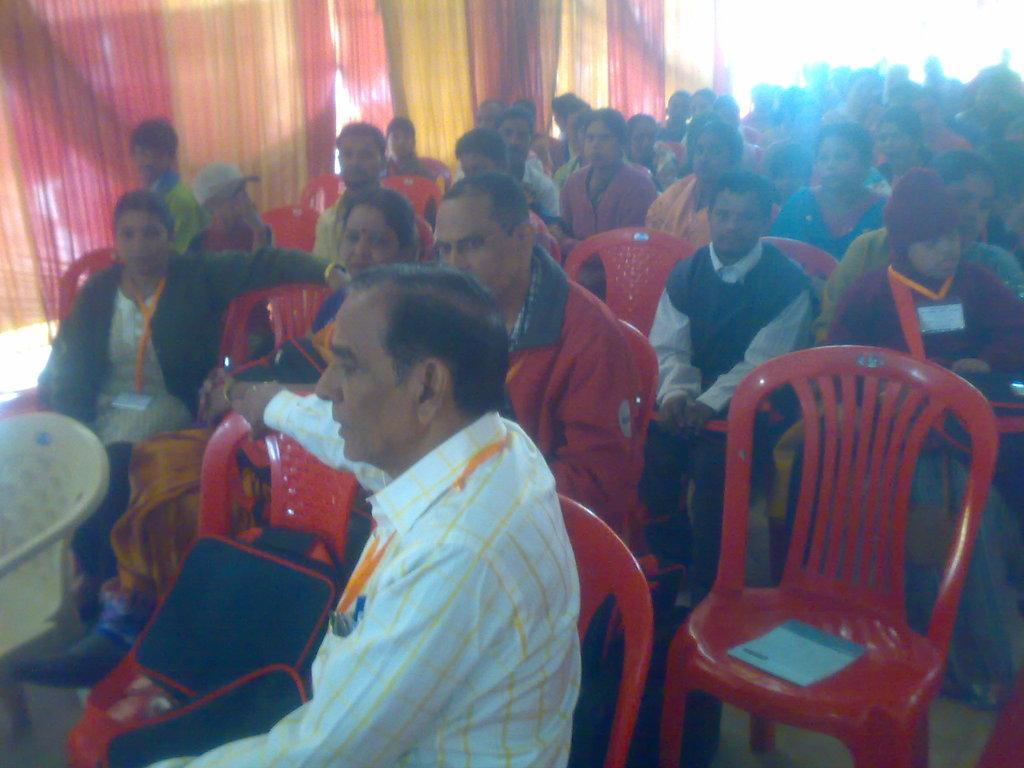Describe this image in one or two sentences. There are some group of people sitting here in the chairs. Some of the chairs are empty and there are some men and women in this group. 